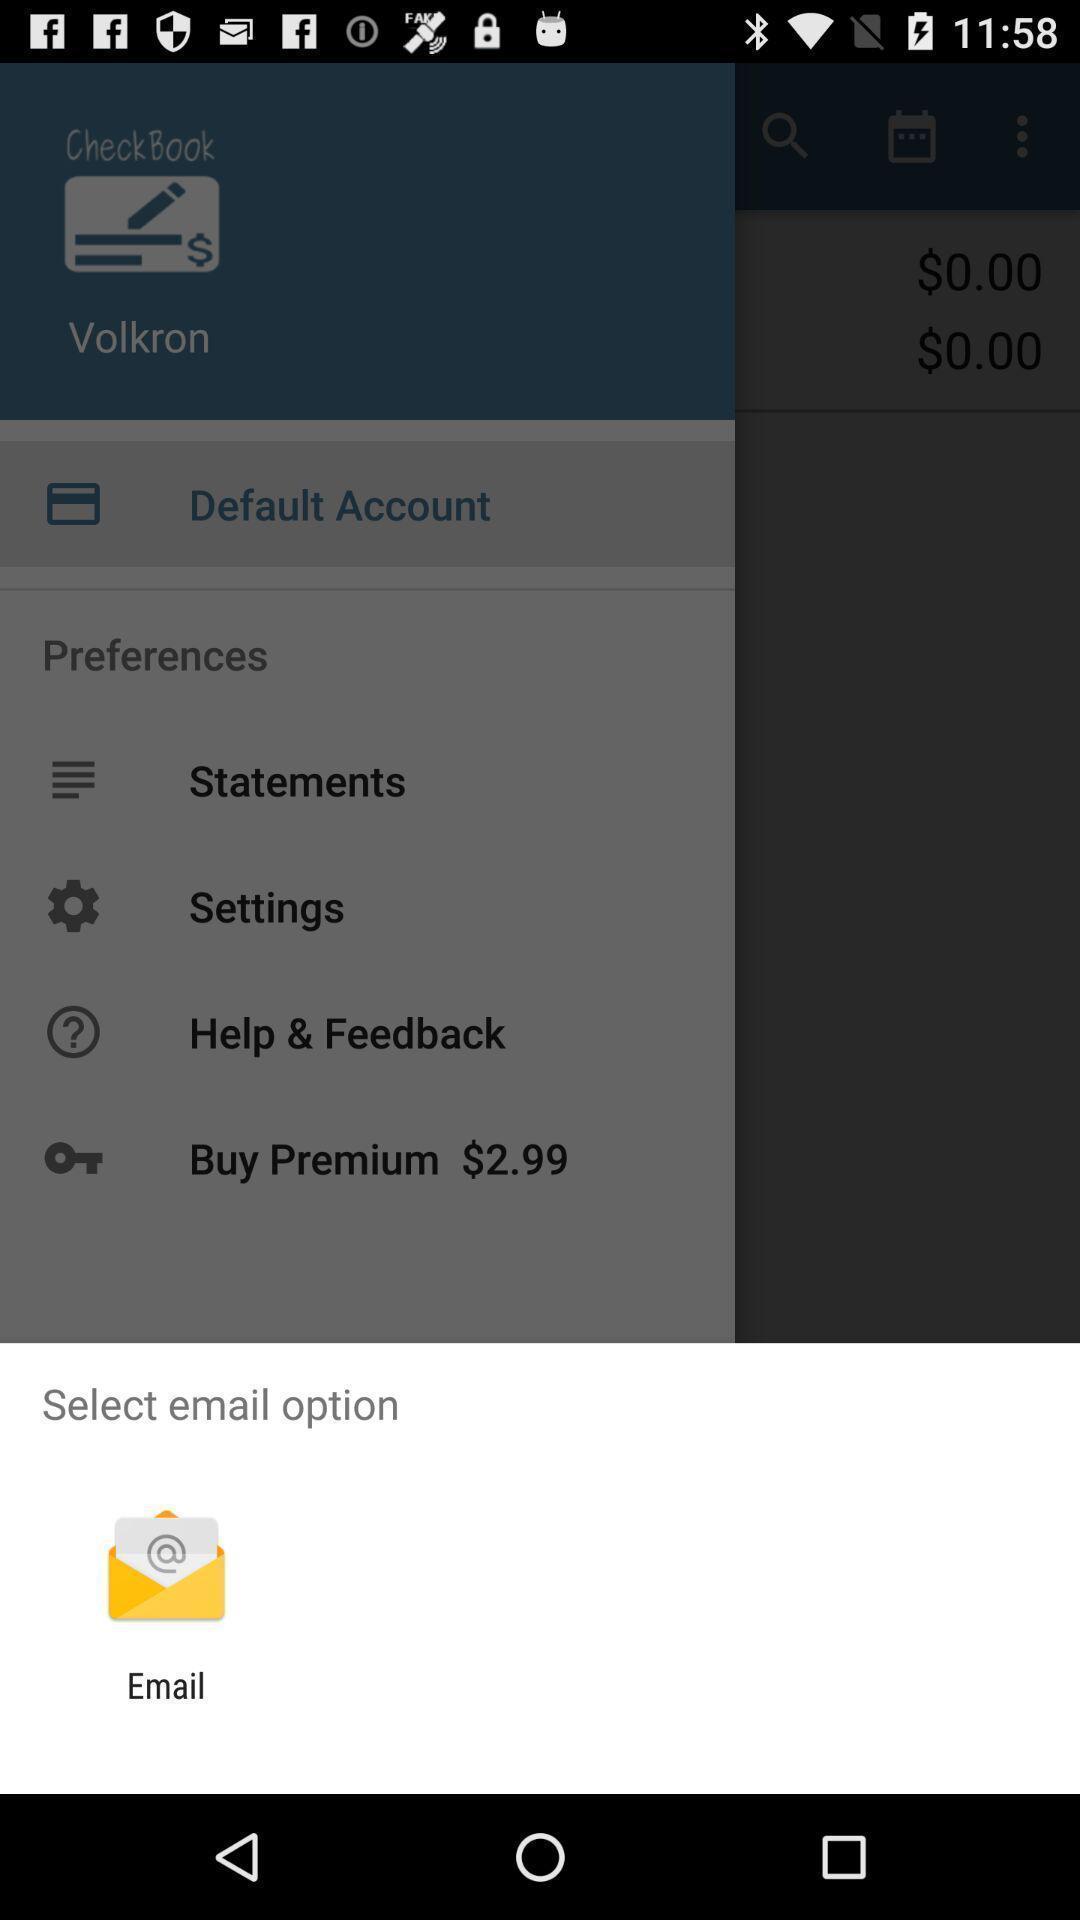Provide a description of this screenshot. Popup to select email option for the payment app. 